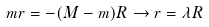Convert formula to latex. <formula><loc_0><loc_0><loc_500><loc_500>m r = - ( M - m ) R \rightarrow r = \lambda R</formula> 